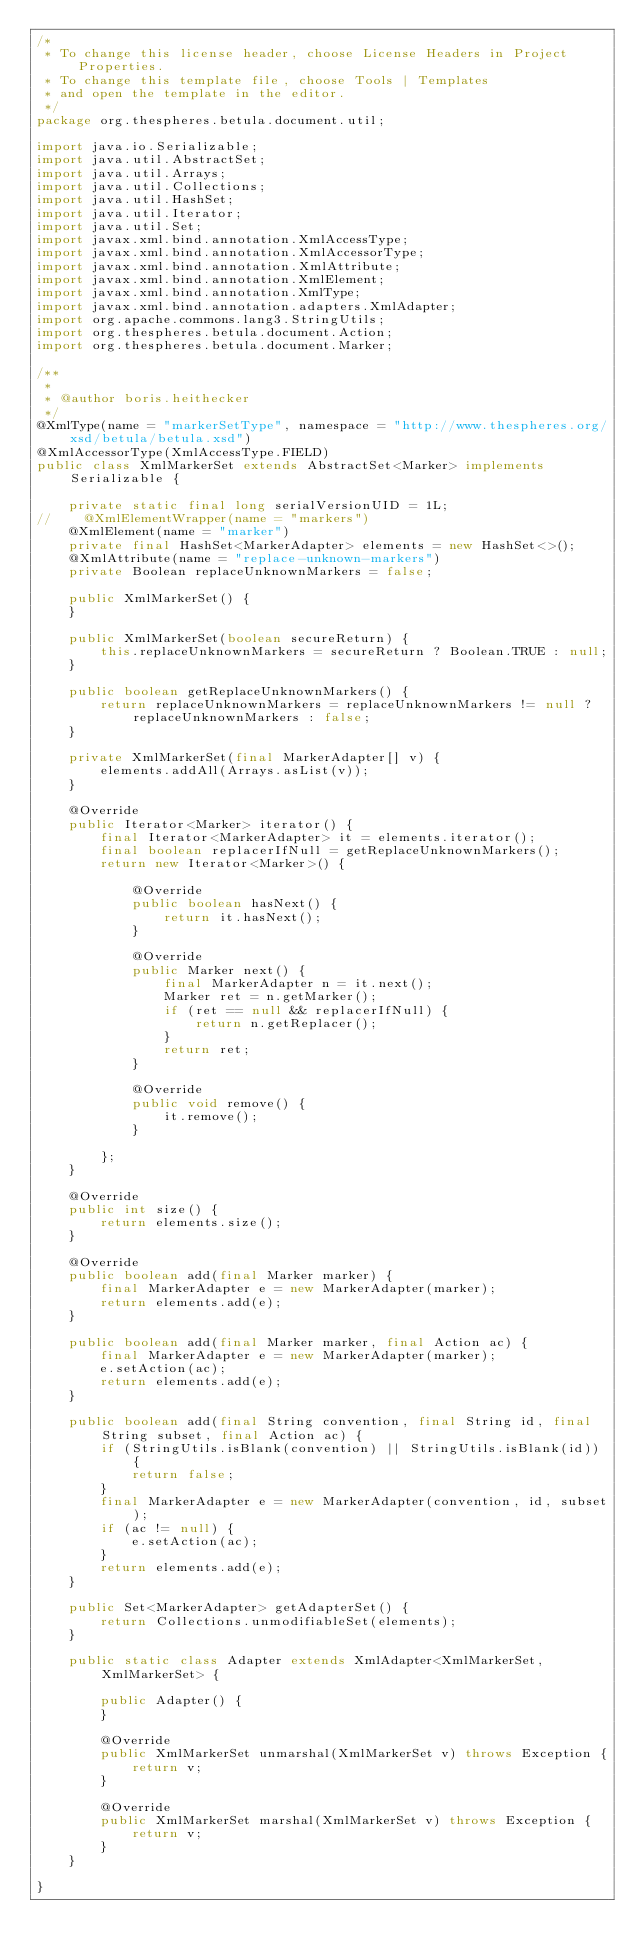<code> <loc_0><loc_0><loc_500><loc_500><_Java_>/*
 * To change this license header, choose License Headers in Project Properties.
 * To change this template file, choose Tools | Templates
 * and open the template in the editor.
 */
package org.thespheres.betula.document.util;

import java.io.Serializable;
import java.util.AbstractSet;
import java.util.Arrays;
import java.util.Collections;
import java.util.HashSet;
import java.util.Iterator;
import java.util.Set;
import javax.xml.bind.annotation.XmlAccessType;
import javax.xml.bind.annotation.XmlAccessorType;
import javax.xml.bind.annotation.XmlAttribute;
import javax.xml.bind.annotation.XmlElement;
import javax.xml.bind.annotation.XmlType;
import javax.xml.bind.annotation.adapters.XmlAdapter;
import org.apache.commons.lang3.StringUtils;
import org.thespheres.betula.document.Action;
import org.thespheres.betula.document.Marker;

/**
 *
 * @author boris.heithecker
 */
@XmlType(name = "markerSetType", namespace = "http://www.thespheres.org/xsd/betula/betula.xsd")
@XmlAccessorType(XmlAccessType.FIELD)
public class XmlMarkerSet extends AbstractSet<Marker> implements Serializable {

    private static final long serialVersionUID = 1L;
//    @XmlElementWrapper(name = "markers")
    @XmlElement(name = "marker")
    private final HashSet<MarkerAdapter> elements = new HashSet<>();
    @XmlAttribute(name = "replace-unknown-markers")
    private Boolean replaceUnknownMarkers = false;

    public XmlMarkerSet() {
    }

    public XmlMarkerSet(boolean secureReturn) {
        this.replaceUnknownMarkers = secureReturn ? Boolean.TRUE : null;
    }

    public boolean getReplaceUnknownMarkers() {
        return replaceUnknownMarkers = replaceUnknownMarkers != null ? replaceUnknownMarkers : false;
    }

    private XmlMarkerSet(final MarkerAdapter[] v) {
        elements.addAll(Arrays.asList(v));
    }

    @Override
    public Iterator<Marker> iterator() {
        final Iterator<MarkerAdapter> it = elements.iterator();
        final boolean replacerIfNull = getReplaceUnknownMarkers();
        return new Iterator<Marker>() {

            @Override
            public boolean hasNext() {
                return it.hasNext();
            }

            @Override
            public Marker next() {
                final MarkerAdapter n = it.next();
                Marker ret = n.getMarker();
                if (ret == null && replacerIfNull) {
                    return n.getReplacer();
                }
                return ret;
            }

            @Override
            public void remove() {
                it.remove();
            }

        };
    }

    @Override
    public int size() {
        return elements.size();
    }

    @Override
    public boolean add(final Marker marker) {
        final MarkerAdapter e = new MarkerAdapter(marker);
        return elements.add(e);
    }

    public boolean add(final Marker marker, final Action ac) {
        final MarkerAdapter e = new MarkerAdapter(marker);
        e.setAction(ac);
        return elements.add(e);
    }

    public boolean add(final String convention, final String id, final String subset, final Action ac) {
        if (StringUtils.isBlank(convention) || StringUtils.isBlank(id)) {
            return false;
        }
        final MarkerAdapter e = new MarkerAdapter(convention, id, subset);
        if (ac != null) {
            e.setAction(ac);
        }
        return elements.add(e);
    }

    public Set<MarkerAdapter> getAdapterSet() {
        return Collections.unmodifiableSet(elements);
    }

    public static class Adapter extends XmlAdapter<XmlMarkerSet, XmlMarkerSet> {

        public Adapter() {
        }

        @Override
        public XmlMarkerSet unmarshal(XmlMarkerSet v) throws Exception {
            return v;
        }

        @Override
        public XmlMarkerSet marshal(XmlMarkerSet v) throws Exception {
            return v;
        }
    }

}
</code> 